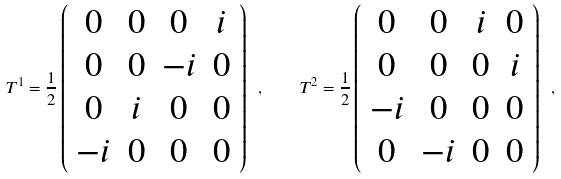<formula> <loc_0><loc_0><loc_500><loc_500>T ^ { 1 } = \frac { 1 } { 2 } \left ( \begin{array} { c c c c } 0 & 0 & 0 & i \\ 0 & 0 & - i & 0 \\ 0 & i & 0 & 0 \\ - i & 0 & 0 & 0 \end{array} \right ) \ , \quad T ^ { 2 } = \frac { 1 } { 2 } \left ( \begin{array} { c c c c } 0 & 0 & i & 0 \\ 0 & 0 & 0 & i \\ - i & 0 & 0 & 0 \\ 0 & - i & 0 & 0 \end{array} \right ) \ ,</formula> 